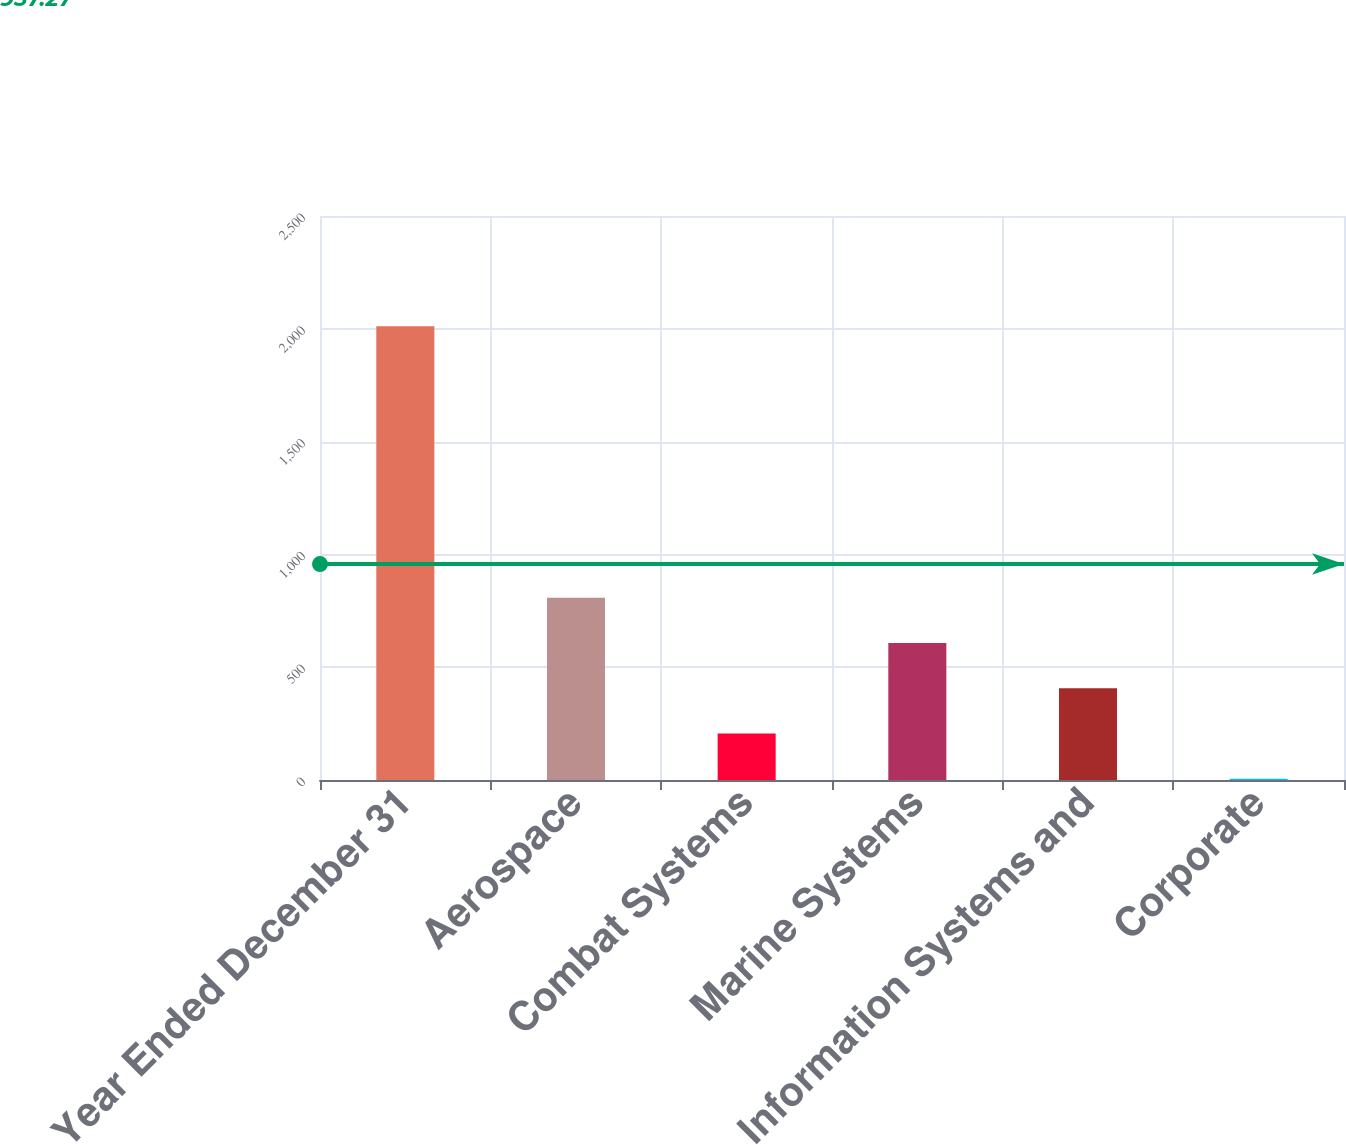<chart> <loc_0><loc_0><loc_500><loc_500><bar_chart><fcel>Year Ended December 31<fcel>Aerospace<fcel>Combat Systems<fcel>Marine Systems<fcel>Information Systems and<fcel>Corporate<nl><fcel>2011<fcel>808<fcel>206.5<fcel>607.5<fcel>407<fcel>6<nl></chart> 